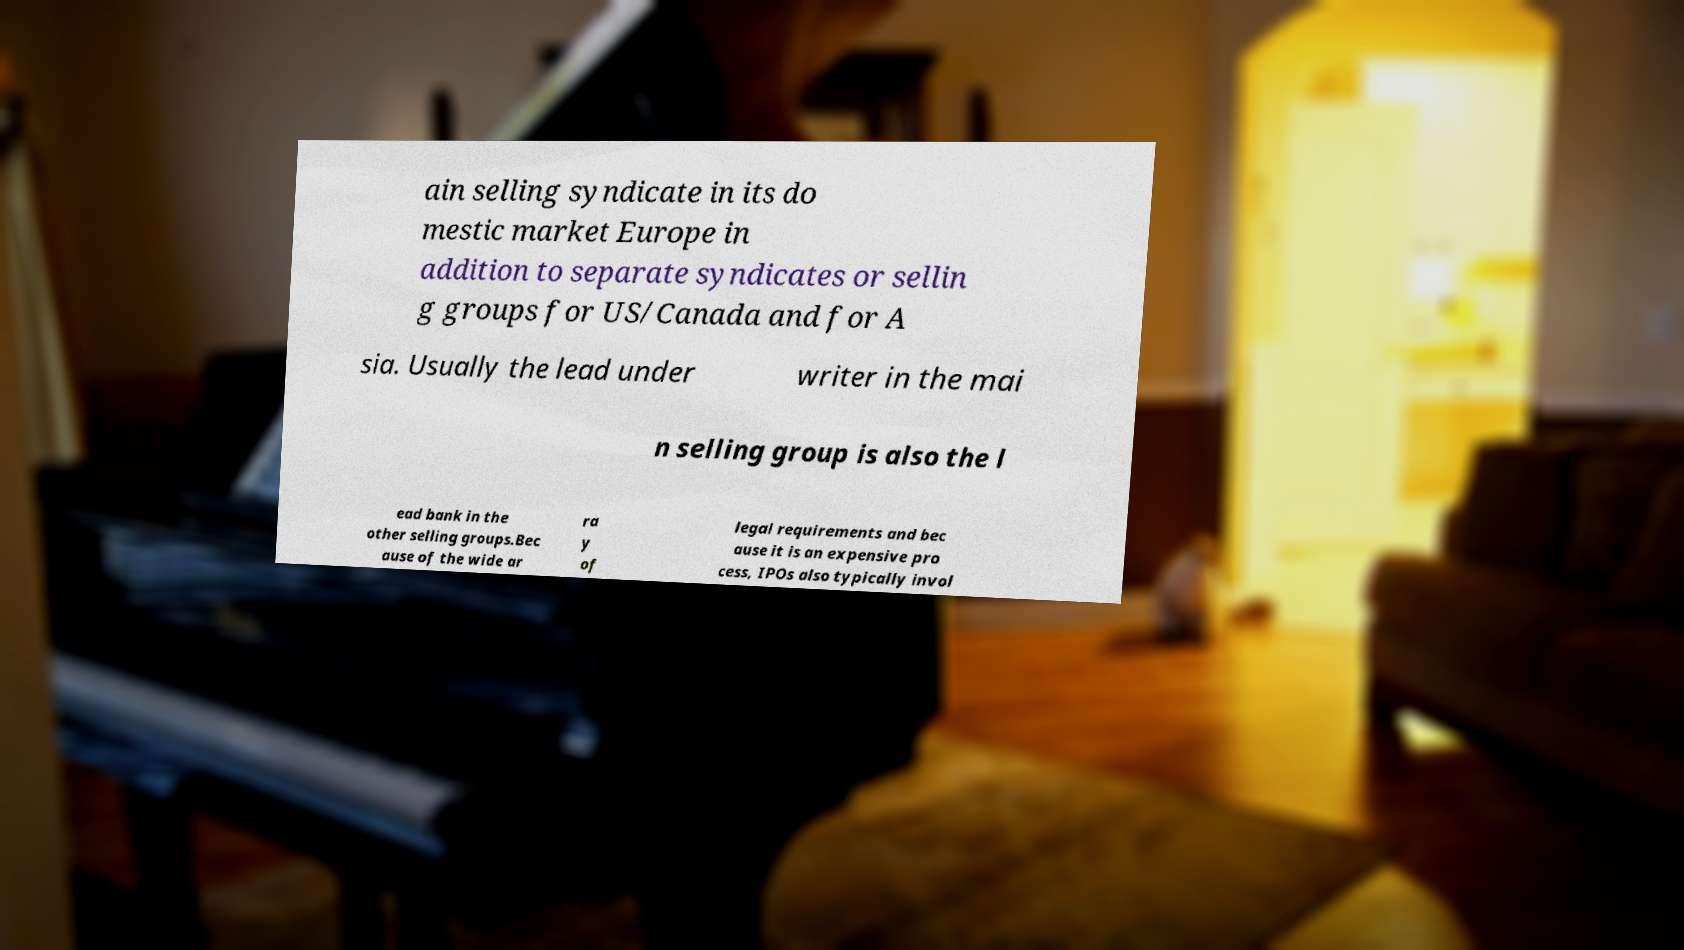Please read and relay the text visible in this image. What does it say? ain selling syndicate in its do mestic market Europe in addition to separate syndicates or sellin g groups for US/Canada and for A sia. Usually the lead under writer in the mai n selling group is also the l ead bank in the other selling groups.Bec ause of the wide ar ra y of legal requirements and bec ause it is an expensive pro cess, IPOs also typically invol 